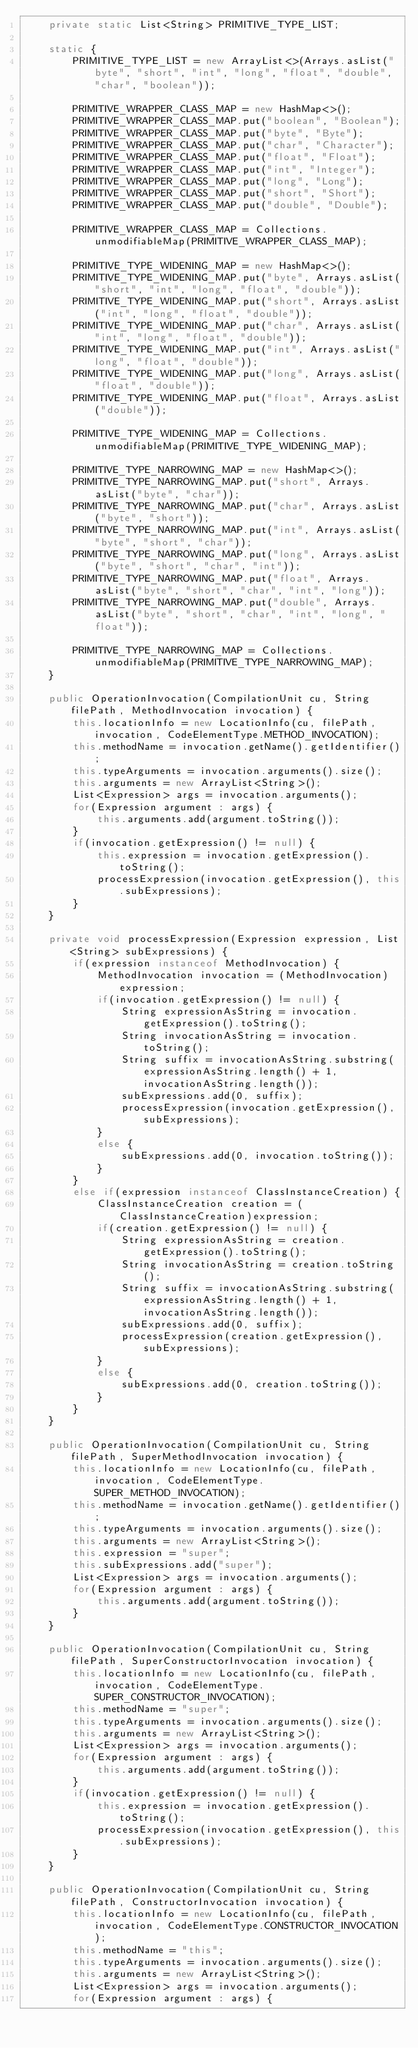Convert code to text. <code><loc_0><loc_0><loc_500><loc_500><_Java_>    private static List<String> PRIMITIVE_TYPE_LIST;

    static {
    	PRIMITIVE_TYPE_LIST = new ArrayList<>(Arrays.asList("byte", "short", "int", "long", "float", "double", "char", "boolean"));
    	
    	PRIMITIVE_WRAPPER_CLASS_MAP = new HashMap<>();
        PRIMITIVE_WRAPPER_CLASS_MAP.put("boolean", "Boolean");
        PRIMITIVE_WRAPPER_CLASS_MAP.put("byte", "Byte");
        PRIMITIVE_WRAPPER_CLASS_MAP.put("char", "Character");
        PRIMITIVE_WRAPPER_CLASS_MAP.put("float", "Float");
        PRIMITIVE_WRAPPER_CLASS_MAP.put("int", "Integer");
        PRIMITIVE_WRAPPER_CLASS_MAP.put("long", "Long");
        PRIMITIVE_WRAPPER_CLASS_MAP.put("short", "Short");
        PRIMITIVE_WRAPPER_CLASS_MAP.put("double", "Double");

        PRIMITIVE_WRAPPER_CLASS_MAP = Collections.unmodifiableMap(PRIMITIVE_WRAPPER_CLASS_MAP);

        PRIMITIVE_TYPE_WIDENING_MAP = new HashMap<>();
        PRIMITIVE_TYPE_WIDENING_MAP.put("byte", Arrays.asList("short", "int", "long", "float", "double"));
        PRIMITIVE_TYPE_WIDENING_MAP.put("short", Arrays.asList("int", "long", "float", "double"));
        PRIMITIVE_TYPE_WIDENING_MAP.put("char", Arrays.asList("int", "long", "float", "double"));
        PRIMITIVE_TYPE_WIDENING_MAP.put("int", Arrays.asList("long", "float", "double"));
        PRIMITIVE_TYPE_WIDENING_MAP.put("long", Arrays.asList("float", "double"));
        PRIMITIVE_TYPE_WIDENING_MAP.put("float", Arrays.asList("double"));

        PRIMITIVE_TYPE_WIDENING_MAP = Collections.unmodifiableMap(PRIMITIVE_TYPE_WIDENING_MAP);

        PRIMITIVE_TYPE_NARROWING_MAP = new HashMap<>();
        PRIMITIVE_TYPE_NARROWING_MAP.put("short", Arrays.asList("byte", "char"));
        PRIMITIVE_TYPE_NARROWING_MAP.put("char", Arrays.asList("byte", "short"));
        PRIMITIVE_TYPE_NARROWING_MAP.put("int", Arrays.asList("byte", "short", "char"));
        PRIMITIVE_TYPE_NARROWING_MAP.put("long", Arrays.asList("byte", "short", "char", "int"));
        PRIMITIVE_TYPE_NARROWING_MAP.put("float", Arrays.asList("byte", "short", "char", "int", "long"));
        PRIMITIVE_TYPE_NARROWING_MAP.put("double", Arrays.asList("byte", "short", "char", "int", "long", "float"));

        PRIMITIVE_TYPE_NARROWING_MAP = Collections.unmodifiableMap(PRIMITIVE_TYPE_NARROWING_MAP);
    }

	public OperationInvocation(CompilationUnit cu, String filePath, MethodInvocation invocation) {
		this.locationInfo = new LocationInfo(cu, filePath, invocation, CodeElementType.METHOD_INVOCATION);
		this.methodName = invocation.getName().getIdentifier();
		this.typeArguments = invocation.arguments().size();
		this.arguments = new ArrayList<String>();
		List<Expression> args = invocation.arguments();
		for(Expression argument : args) {
			this.arguments.add(argument.toString());
		}
		if(invocation.getExpression() != null) {
			this.expression = invocation.getExpression().toString();
			processExpression(invocation.getExpression(), this.subExpressions);
		}
	}
	
	private void processExpression(Expression expression, List<String> subExpressions) {
		if(expression instanceof MethodInvocation) {
			MethodInvocation invocation = (MethodInvocation)expression;
			if(invocation.getExpression() != null) {
				String expressionAsString = invocation.getExpression().toString();
				String invocationAsString = invocation.toString();
				String suffix = invocationAsString.substring(expressionAsString.length() + 1, invocationAsString.length());
				subExpressions.add(0, suffix);
				processExpression(invocation.getExpression(), subExpressions);
			}
			else {
				subExpressions.add(0, invocation.toString());
			}
		}
		else if(expression instanceof ClassInstanceCreation) {
			ClassInstanceCreation creation = (ClassInstanceCreation)expression;
			if(creation.getExpression() != null) {
				String expressionAsString = creation.getExpression().toString();
				String invocationAsString = creation.toString();
				String suffix = invocationAsString.substring(expressionAsString.length() + 1, invocationAsString.length());
				subExpressions.add(0, suffix);
				processExpression(creation.getExpression(), subExpressions);
			}
			else {
				subExpressions.add(0, creation.toString());
			}
		}
	}

	public OperationInvocation(CompilationUnit cu, String filePath, SuperMethodInvocation invocation) {
		this.locationInfo = new LocationInfo(cu, filePath, invocation, CodeElementType.SUPER_METHOD_INVOCATION);
		this.methodName = invocation.getName().getIdentifier();
		this.typeArguments = invocation.arguments().size();
		this.arguments = new ArrayList<String>();
		this.expression = "super";
		this.subExpressions.add("super");
		List<Expression> args = invocation.arguments();
		for(Expression argument : args) {
			this.arguments.add(argument.toString());
		}
	}

	public OperationInvocation(CompilationUnit cu, String filePath, SuperConstructorInvocation invocation) {
		this.locationInfo = new LocationInfo(cu, filePath, invocation, CodeElementType.SUPER_CONSTRUCTOR_INVOCATION);
		this.methodName = "super";
		this.typeArguments = invocation.arguments().size();
		this.arguments = new ArrayList<String>();
		List<Expression> args = invocation.arguments();
		for(Expression argument : args) {
			this.arguments.add(argument.toString());
		}
		if(invocation.getExpression() != null) {
			this.expression = invocation.getExpression().toString();
			processExpression(invocation.getExpression(), this.subExpressions);
		}
	}

	public OperationInvocation(CompilationUnit cu, String filePath, ConstructorInvocation invocation) {
		this.locationInfo = new LocationInfo(cu, filePath, invocation, CodeElementType.CONSTRUCTOR_INVOCATION);
		this.methodName = "this";
		this.typeArguments = invocation.arguments().size();
		this.arguments = new ArrayList<String>();
		List<Expression> args = invocation.arguments();
		for(Expression argument : args) {</code> 